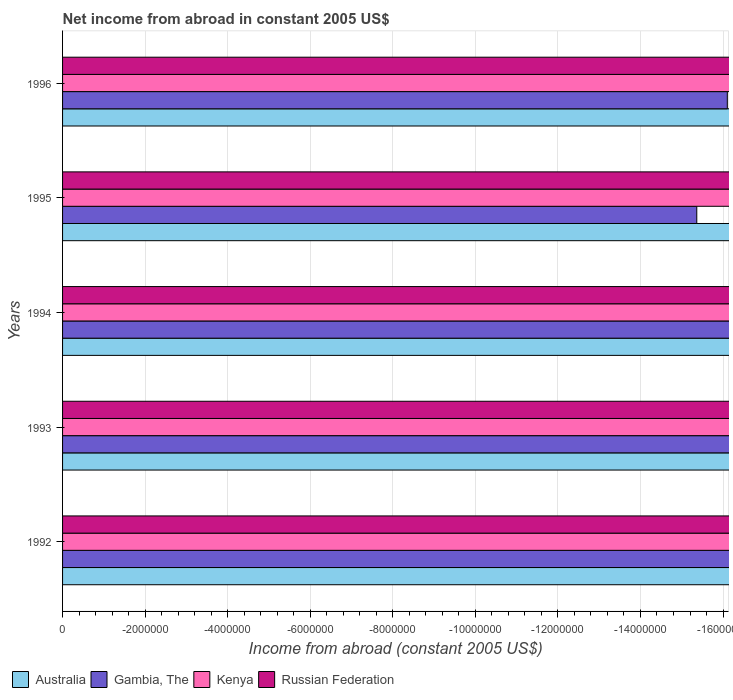How many different coloured bars are there?
Provide a succinct answer. 0. Are the number of bars per tick equal to the number of legend labels?
Your response must be concise. No. How many bars are there on the 1st tick from the top?
Offer a very short reply. 0. What is the average net income from abroad in Australia per year?
Provide a short and direct response. 0. In how many years, is the net income from abroad in Australia greater than -2400000 US$?
Provide a short and direct response. 0. In how many years, is the net income from abroad in Australia greater than the average net income from abroad in Australia taken over all years?
Your answer should be compact. 0. Is it the case that in every year, the sum of the net income from abroad in Russian Federation and net income from abroad in Gambia, The is greater than the sum of net income from abroad in Australia and net income from abroad in Kenya?
Your answer should be compact. No. Is it the case that in every year, the sum of the net income from abroad in Kenya and net income from abroad in Russian Federation is greater than the net income from abroad in Gambia, The?
Provide a succinct answer. No. How many bars are there?
Offer a very short reply. 0. Are all the bars in the graph horizontal?
Give a very brief answer. Yes. Are the values on the major ticks of X-axis written in scientific E-notation?
Your answer should be compact. No. Does the graph contain any zero values?
Your answer should be compact. Yes. Does the graph contain grids?
Your answer should be very brief. Yes. What is the title of the graph?
Your answer should be very brief. Net income from abroad in constant 2005 US$. Does "Madagascar" appear as one of the legend labels in the graph?
Offer a very short reply. No. What is the label or title of the X-axis?
Your response must be concise. Income from abroad (constant 2005 US$). What is the label or title of the Y-axis?
Offer a very short reply. Years. What is the Income from abroad (constant 2005 US$) of Australia in 1992?
Your answer should be compact. 0. What is the Income from abroad (constant 2005 US$) of Russian Federation in 1992?
Provide a succinct answer. 0. What is the Income from abroad (constant 2005 US$) in Kenya in 1993?
Offer a very short reply. 0. What is the Income from abroad (constant 2005 US$) in Gambia, The in 1994?
Your answer should be compact. 0. What is the Income from abroad (constant 2005 US$) of Kenya in 1994?
Keep it short and to the point. 0. What is the Income from abroad (constant 2005 US$) in Australia in 1995?
Ensure brevity in your answer.  0. What is the Income from abroad (constant 2005 US$) in Russian Federation in 1995?
Give a very brief answer. 0. What is the Income from abroad (constant 2005 US$) in Gambia, The in 1996?
Offer a terse response. 0. What is the Income from abroad (constant 2005 US$) of Kenya in 1996?
Your response must be concise. 0. What is the total Income from abroad (constant 2005 US$) in Kenya in the graph?
Ensure brevity in your answer.  0. What is the average Income from abroad (constant 2005 US$) in Australia per year?
Provide a short and direct response. 0. What is the average Income from abroad (constant 2005 US$) of Gambia, The per year?
Make the answer very short. 0. 